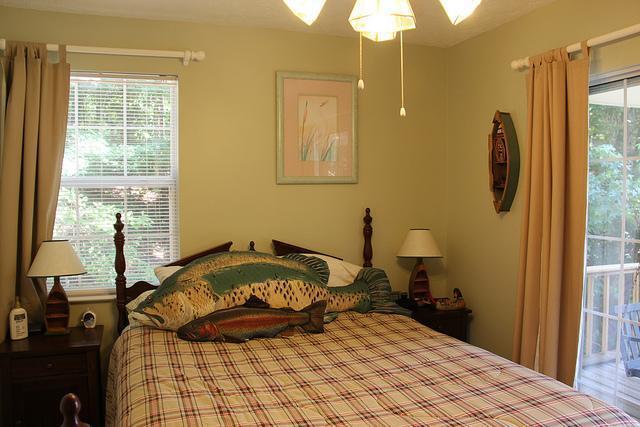How many fish are on the bed?
Give a very brief answer. 2. 